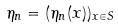Convert formula to latex. <formula><loc_0><loc_0><loc_500><loc_500>\eta _ { n } = ( \eta _ { n } ( x ) ) _ { x \in S }</formula> 